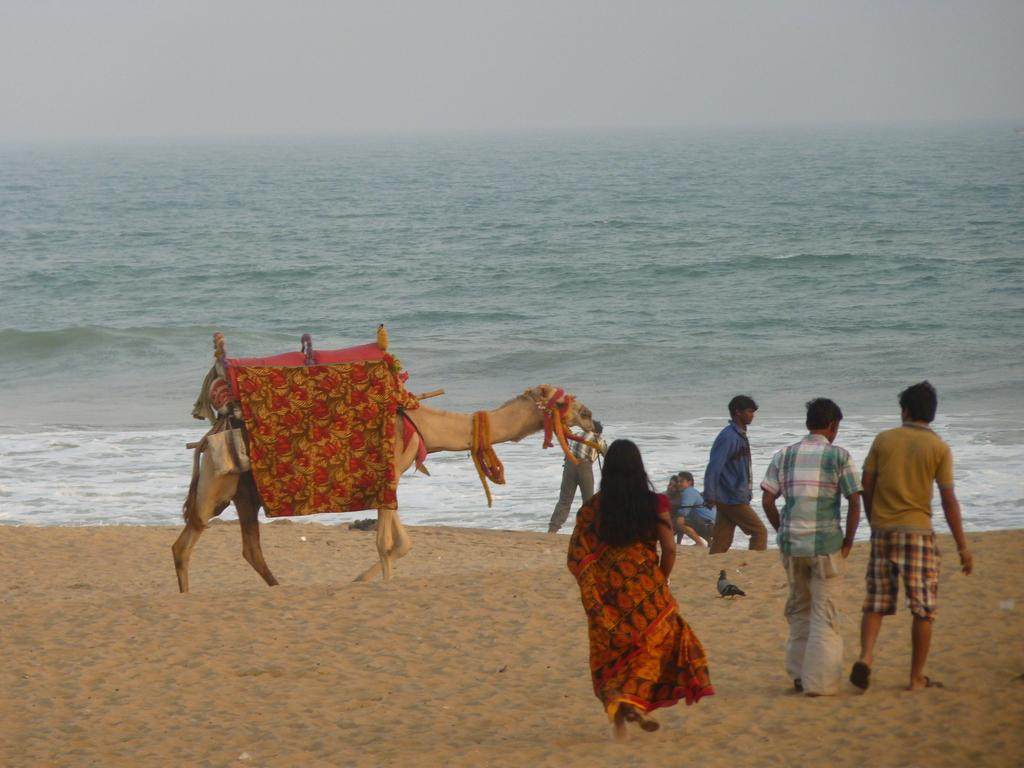What type of surface is visible in the image? The image shows a sand surface. What are the people and the camel doing on the sand? The people and the camel are walking on the sand. What can be seen in the background of the image? Water and the sky are visible in the background. What is the condition of the mountain in the image? There is no mountain present in the image. How many buildings are visible in the town in the image? There is no town present in the image. 